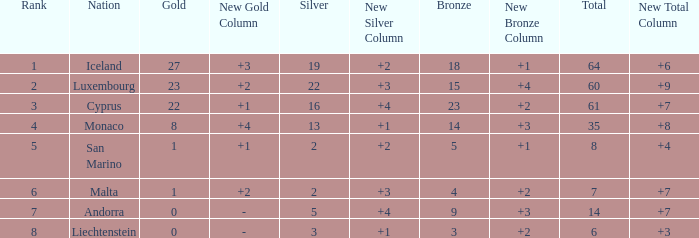How many golds for the nation with 14 total? 0.0. 